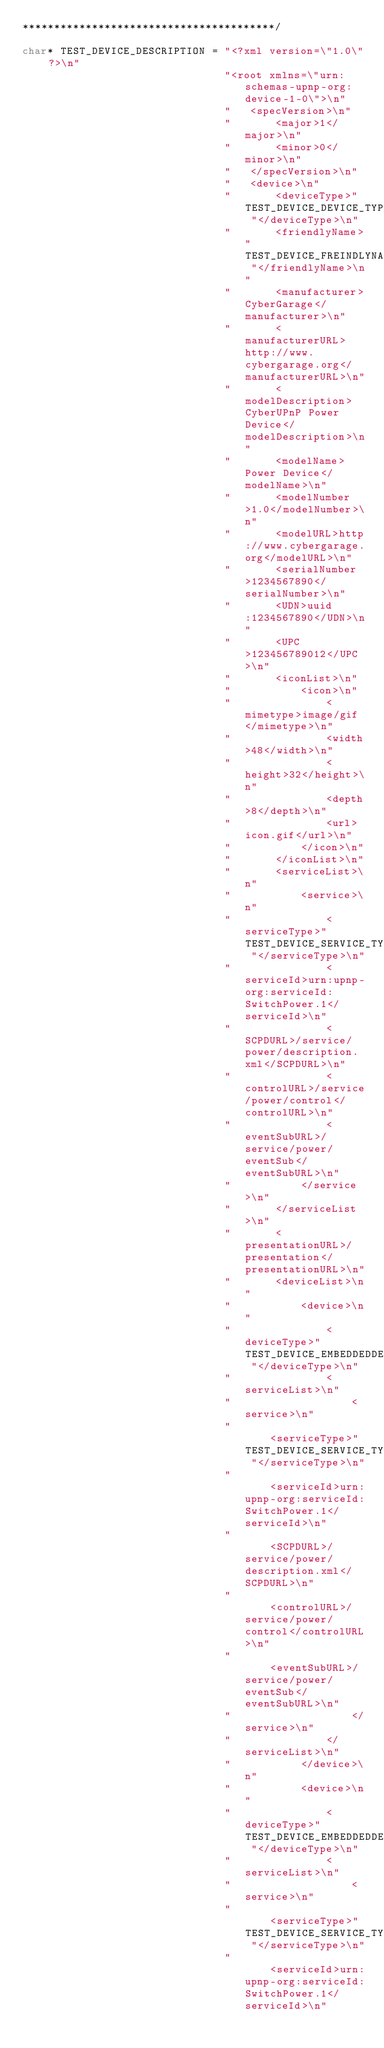<code> <loc_0><loc_0><loc_500><loc_500><_C_>****************************************/

char* TEST_DEVICE_DESCRIPTION = "<?xml version=\"1.0\" ?>\n"
                                "<root xmlns=\"urn:schemas-upnp-org:device-1-0\">\n"
                                " 	<specVersion>\n"
                                " 		<major>1</major>\n"
                                " 		<minor>0</minor>\n"
                                " 	</specVersion>\n"
                                " 	<device>\n"
                                " 		<deviceType>" TEST_DEVICE_DEVICE_TYPE "</deviceType>\n"
                                " 		<friendlyName>" TEST_DEVICE_FREINDLYNAME "</friendlyName>\n"
                                " 		<manufacturer>CyberGarage</manufacturer>\n"
                                " 		<manufacturerURL>http://www.cybergarage.org</manufacturerURL>\n"
                                " 		<modelDescription>CyberUPnP Power Device</modelDescription>\n"
                                " 		<modelName>Power Device</modelName>\n"
                                " 		<modelNumber>1.0</modelNumber>\n"
                                " 		<modelURL>http://www.cybergarage.org</modelURL>\n"
                                " 		<serialNumber>1234567890</serialNumber>\n"
                                " 		<UDN>uuid:1234567890</UDN>\n"
                                " 		<UPC>123456789012</UPC>\n"
                                " 		<iconList>\n"
                                " 			<icon>\n"
                                " 				<mimetype>image/gif</mimetype>\n"
                                " 				<width>48</width>\n"
                                " 				<height>32</height>\n"
                                " 				<depth>8</depth>\n"
                                " 				<url>icon.gif</url>\n"
                                " 			</icon>\n"
                                " 		</iconList>\n"
                                " 		<serviceList>\n"
                                " 			<service>\n"
                                " 				<serviceType>" TEST_DEVICE_SERVICE_TYPE "</serviceType>\n"
                                " 				<serviceId>urn:upnp-org:serviceId:SwitchPower.1</serviceId>\n"
                                " 				<SCPDURL>/service/power/description.xml</SCPDURL>\n"
                                " 				<controlURL>/service/power/control</controlURL>\n"
                                " 				<eventSubURL>/service/power/eventSub</eventSubURL>\n"
                                " 			</service>\n"
                                " 		</serviceList>\n"
                                " 		<presentationURL>/presentation</presentationURL>\n"
                                " 		<deviceList>\n"
                                "			<device>\n"
                                " 				<deviceType>" TEST_DEVICE_EMBEDDEDDEVICE_TYPE1 "</deviceType>\n"
                                "				<serviceList>\n"
                                " 					<service>\n"
                                " 						<serviceType>" TEST_DEVICE_SERVICE_TYPE "</serviceType>\n"
                                " 						<serviceId>urn:upnp-org:serviceId:SwitchPower.1</serviceId>\n"
                                " 						<SCPDURL>/service/power/description.xml</SCPDURL>\n"
                                "						<controlURL>/service/power/control</controlURL>\n"
                                " 						<eventSubURL>/service/power/eventSub</eventSubURL>\n"
                                " 					</service>\n"
                                " 				</serviceList>\n"
                                "			</device>\n"
                                "			<device>\n"
                                " 				<deviceType>" TEST_DEVICE_EMBEDDEDDEVICE_TYPE2 "</deviceType>\n"
                                "				<serviceList>\n"
                                " 					<service>\n"
                                " 						<serviceType>" TEST_DEVICE_SERVICE_TYPE "</serviceType>\n"
                                " 						<serviceId>urn:upnp-org:serviceId:SwitchPower.1</serviceId>\n"</code> 